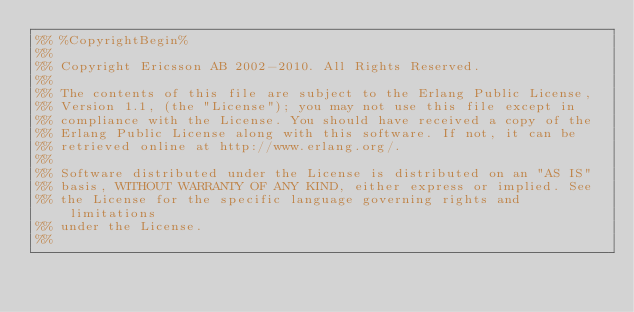<code> <loc_0><loc_0><loc_500><loc_500><_Erlang_>%% %CopyrightBegin%
%%
%% Copyright Ericsson AB 2002-2010. All Rights Reserved.
%%
%% The contents of this file are subject to the Erlang Public License,
%% Version 1.1, (the "License"); you may not use this file except in
%% compliance with the License. You should have received a copy of the
%% Erlang Public License along with this software. If not, it can be
%% retrieved online at http://www.erlang.org/.
%%
%% Software distributed under the License is distributed on an "AS IS"
%% basis, WITHOUT WARRANTY OF ANY KIND, either express or implied. See
%% the License for the specific language governing rights and limitations
%% under the License.
%%</code> 